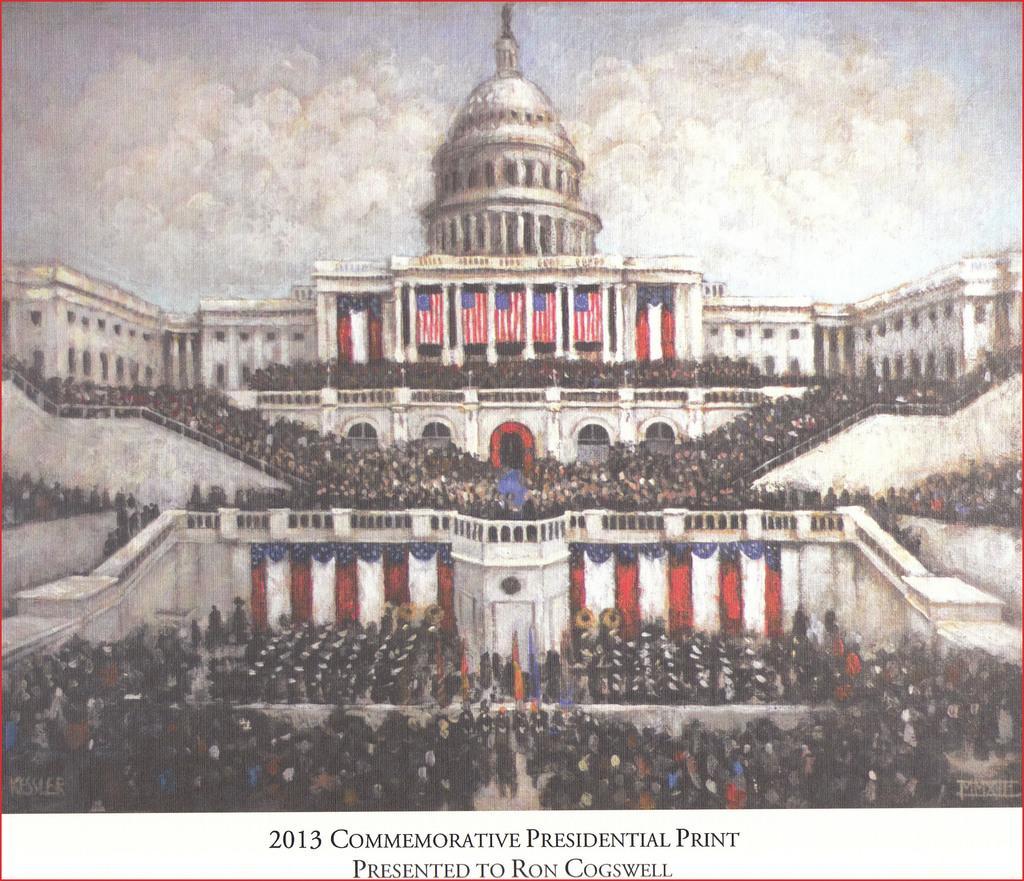Can you describe this image briefly? In this picture we can see a group of people, buildings, flags, railings and some objects and in the background we can see the sky with clouds and at the bottom of this picture we can see some text. 